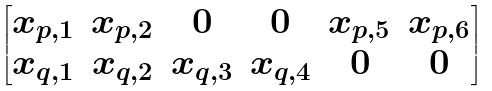Convert formula to latex. <formula><loc_0><loc_0><loc_500><loc_500>\begin{bmatrix} x _ { p , 1 } & x _ { p , 2 } & 0 & 0 & x _ { p , 5 } & x _ { p , 6 } \\ x _ { q , 1 } & x _ { q , 2 } & x _ { q , 3 } & x _ { q , 4 } & 0 & 0 \end{bmatrix}</formula> 